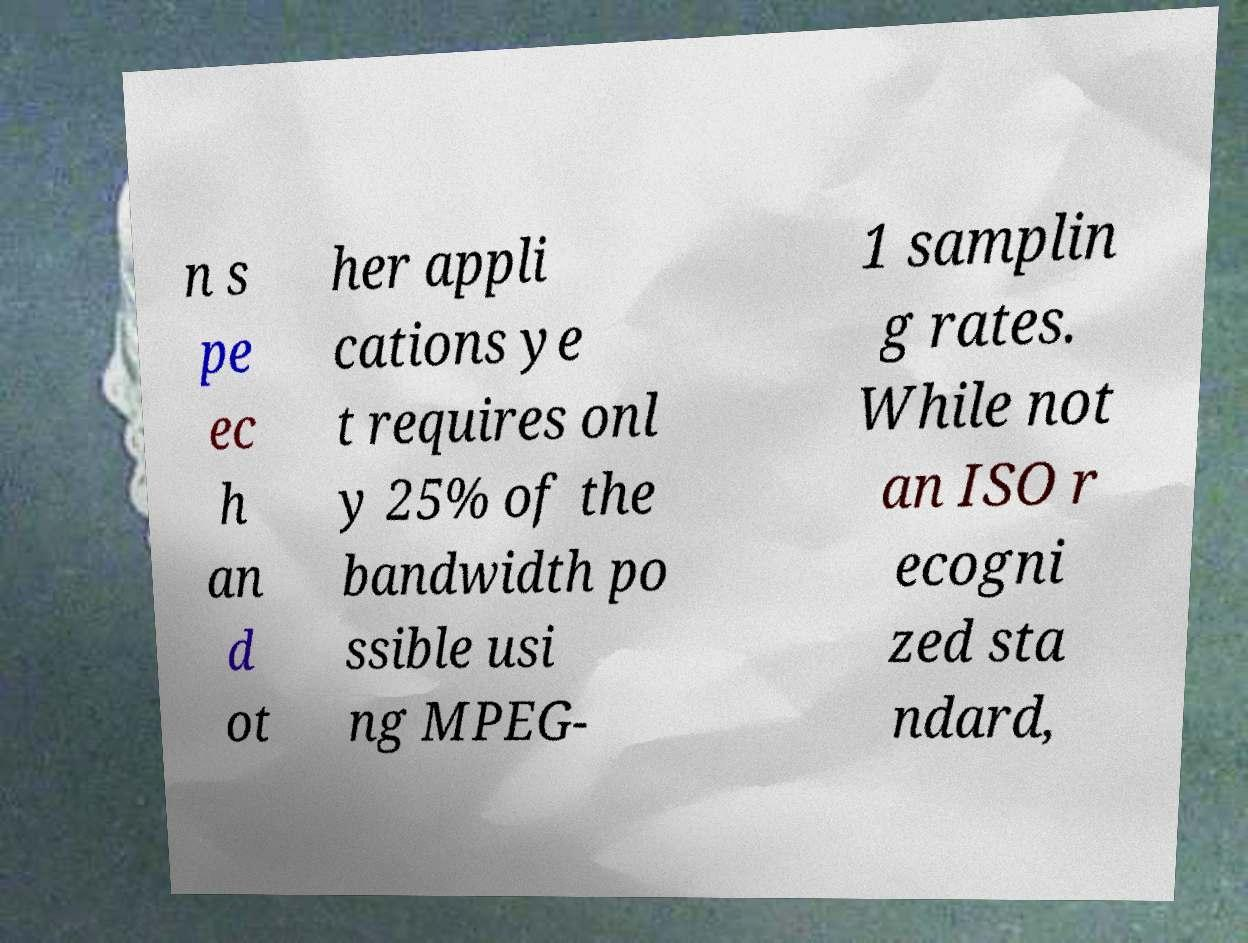Could you extract and type out the text from this image? n s pe ec h an d ot her appli cations ye t requires onl y 25% of the bandwidth po ssible usi ng MPEG- 1 samplin g rates. While not an ISO r ecogni zed sta ndard, 